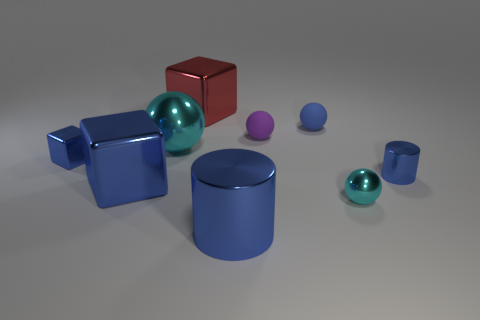Add 1 yellow metal things. How many objects exist? 10 Subtract all cylinders. How many objects are left? 7 Subtract all small yellow spheres. Subtract all blue rubber balls. How many objects are left? 8 Add 6 large metallic spheres. How many large metallic spheres are left? 7 Add 8 small matte balls. How many small matte balls exist? 10 Subtract 2 cyan spheres. How many objects are left? 7 